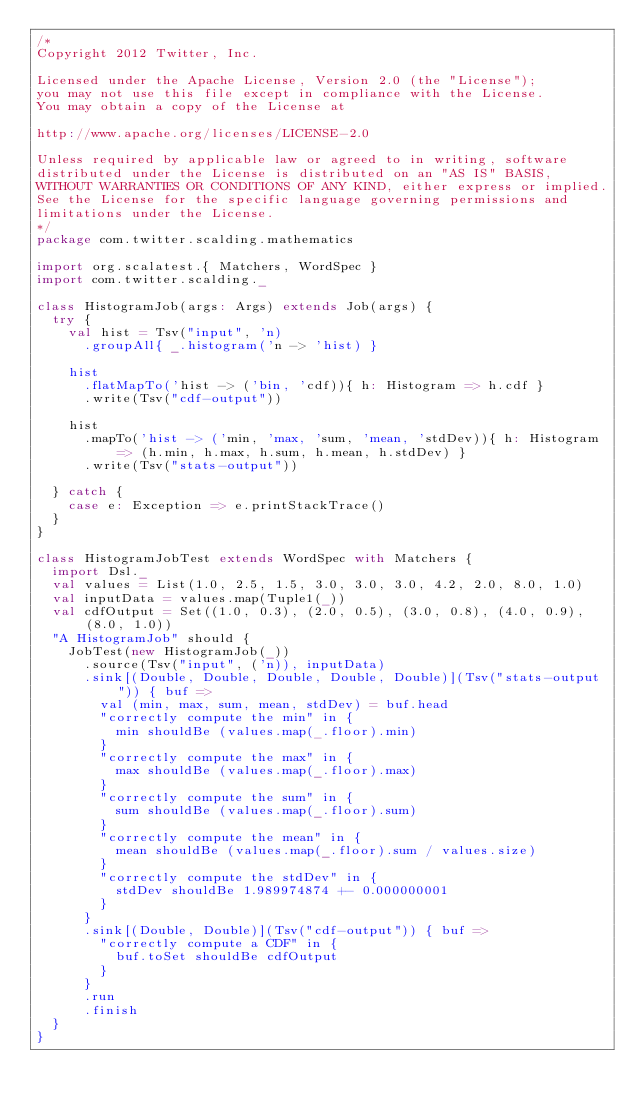<code> <loc_0><loc_0><loc_500><loc_500><_Scala_>/*
Copyright 2012 Twitter, Inc.

Licensed under the Apache License, Version 2.0 (the "License");
you may not use this file except in compliance with the License.
You may obtain a copy of the License at

http://www.apache.org/licenses/LICENSE-2.0

Unless required by applicable law or agreed to in writing, software
distributed under the License is distributed on an "AS IS" BASIS,
WITHOUT WARRANTIES OR CONDITIONS OF ANY KIND, either express or implied.
See the License for the specific language governing permissions and
limitations under the License.
*/
package com.twitter.scalding.mathematics

import org.scalatest.{ Matchers, WordSpec }
import com.twitter.scalding._

class HistogramJob(args: Args) extends Job(args) {
  try {
    val hist = Tsv("input", 'n)
      .groupAll{ _.histogram('n -> 'hist) }

    hist
      .flatMapTo('hist -> ('bin, 'cdf)){ h: Histogram => h.cdf }
      .write(Tsv("cdf-output"))

    hist
      .mapTo('hist -> ('min, 'max, 'sum, 'mean, 'stdDev)){ h: Histogram => (h.min, h.max, h.sum, h.mean, h.stdDev) }
      .write(Tsv("stats-output"))

  } catch {
    case e: Exception => e.printStackTrace()
  }
}

class HistogramJobTest extends WordSpec with Matchers {
  import Dsl._
  val values = List(1.0, 2.5, 1.5, 3.0, 3.0, 3.0, 4.2, 2.0, 8.0, 1.0)
  val inputData = values.map(Tuple1(_))
  val cdfOutput = Set((1.0, 0.3), (2.0, 0.5), (3.0, 0.8), (4.0, 0.9), (8.0, 1.0))
  "A HistogramJob" should {
    JobTest(new HistogramJob(_))
      .source(Tsv("input", ('n)), inputData)
      .sink[(Double, Double, Double, Double, Double)](Tsv("stats-output")) { buf =>
        val (min, max, sum, mean, stdDev) = buf.head
        "correctly compute the min" in {
          min shouldBe (values.map(_.floor).min)
        }
        "correctly compute the max" in {
          max shouldBe (values.map(_.floor).max)
        }
        "correctly compute the sum" in {
          sum shouldBe (values.map(_.floor).sum)
        }
        "correctly compute the mean" in {
          mean shouldBe (values.map(_.floor).sum / values.size)
        }
        "correctly compute the stdDev" in {
          stdDev shouldBe 1.989974874 +- 0.000000001
        }
      }
      .sink[(Double, Double)](Tsv("cdf-output")) { buf =>
        "correctly compute a CDF" in {
          buf.toSet shouldBe cdfOutput
        }
      }
      .run
      .finish
  }
}
</code> 